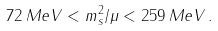Convert formula to latex. <formula><loc_0><loc_0><loc_500><loc_500>7 2 \, M e V < m ^ { 2 } _ { s } / \mu < 2 5 9 \, M e V \, .</formula> 